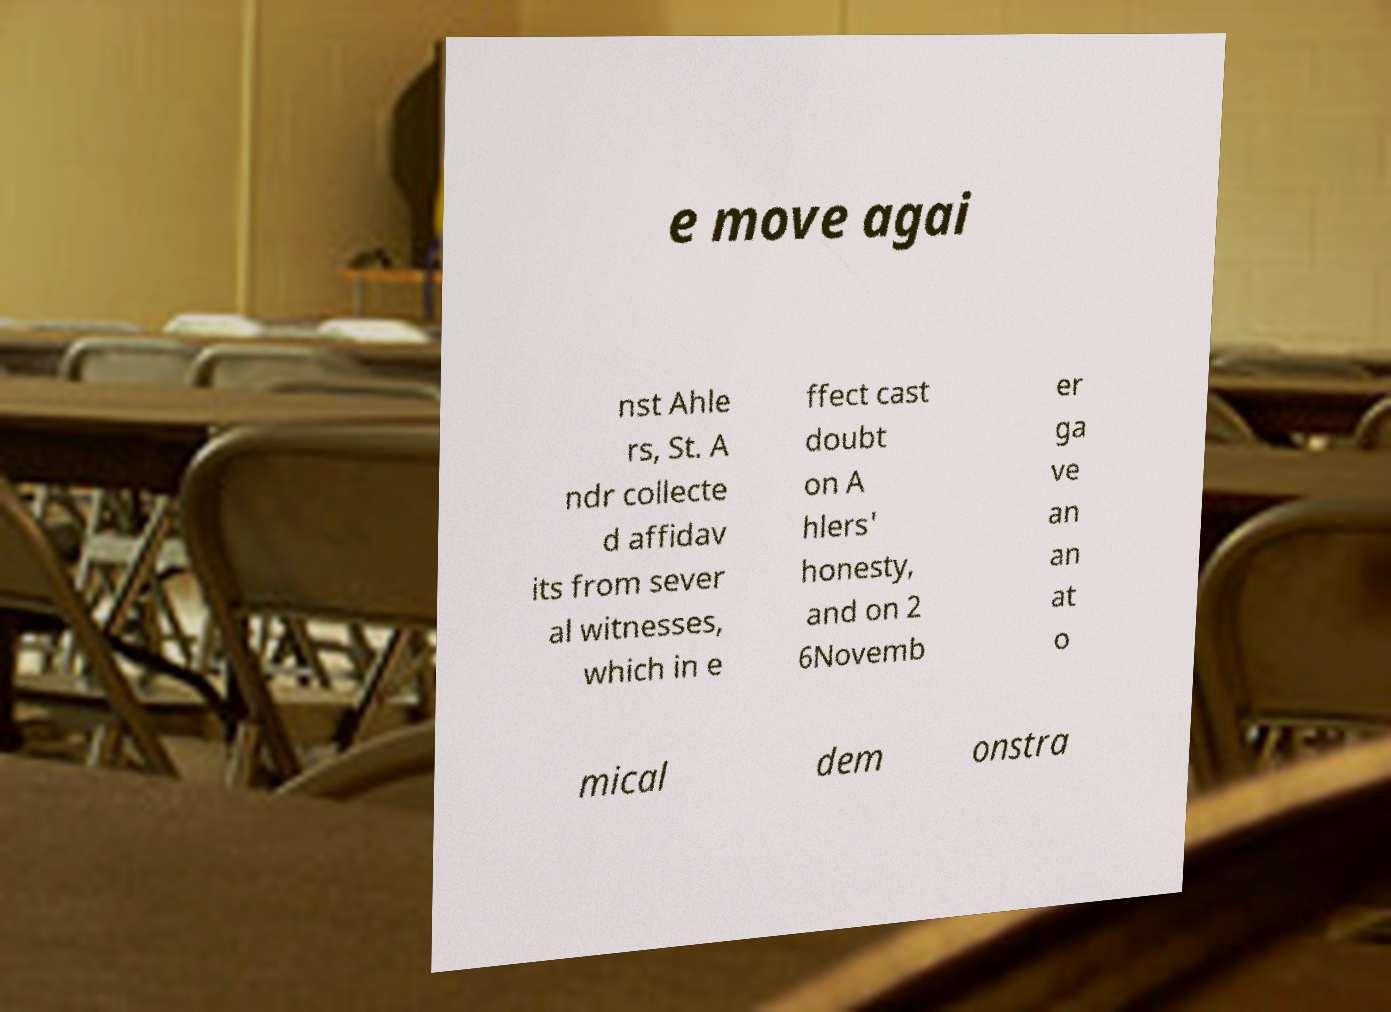Could you assist in decoding the text presented in this image and type it out clearly? e move agai nst Ahle rs, St. A ndr collecte d affidav its from sever al witnesses, which in e ffect cast doubt on A hlers' honesty, and on 2 6Novemb er ga ve an an at o mical dem onstra 